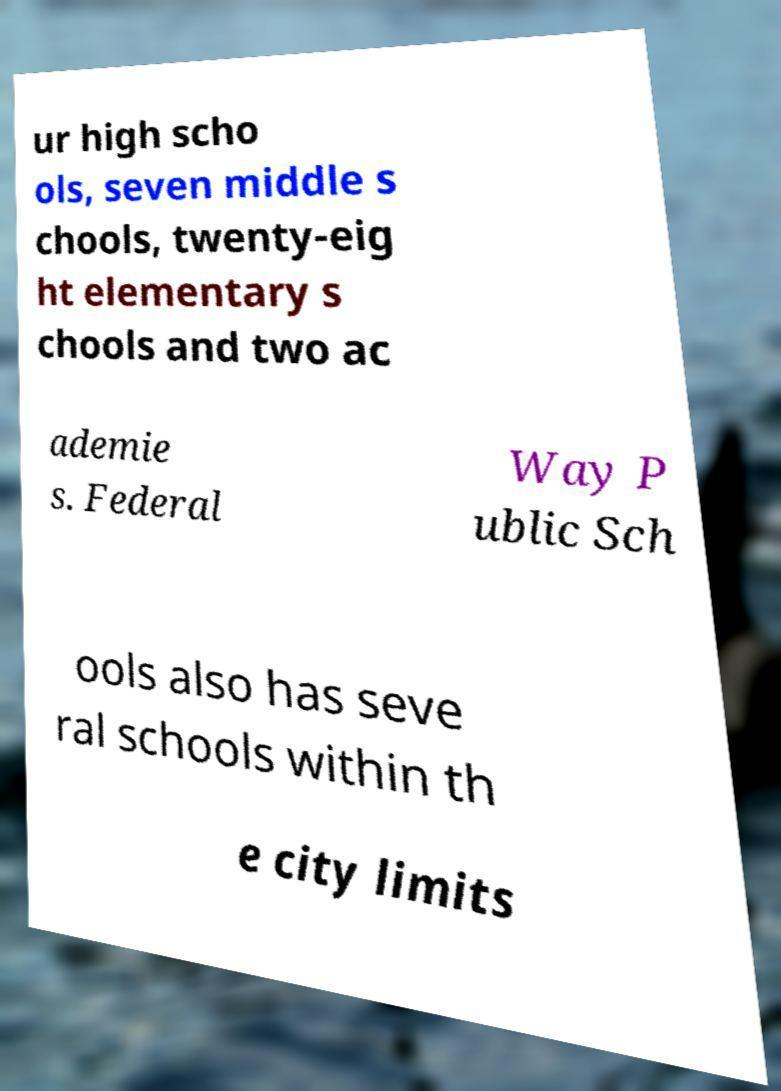What messages or text are displayed in this image? I need them in a readable, typed format. ur high scho ols, seven middle s chools, twenty-eig ht elementary s chools and two ac ademie s. Federal Way P ublic Sch ools also has seve ral schools within th e city limits 